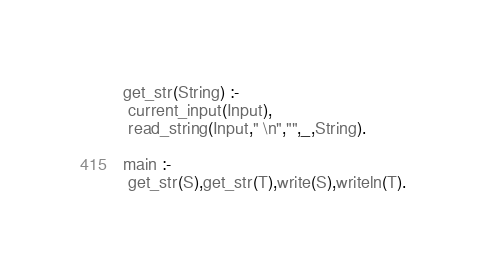<code> <loc_0><loc_0><loc_500><loc_500><_Prolog_>get_str(String) :-
 current_input(Input),
 read_string(Input," \n","",_,String).

main :-
 get_str(S),get_str(T),write(S),writeln(T).</code> 